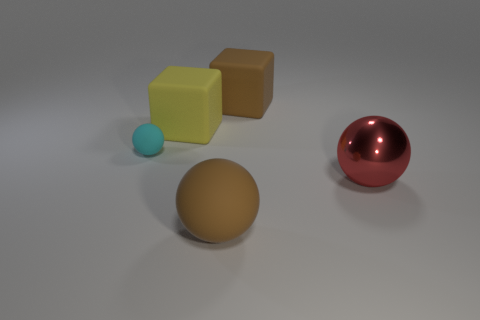Add 2 balls. How many objects exist? 7 Subtract all cubes. How many objects are left? 3 Add 4 yellow matte blocks. How many yellow matte blocks are left? 5 Add 2 rubber objects. How many rubber objects exist? 6 Subtract 0 gray cylinders. How many objects are left? 5 Subtract all large yellow cylinders. Subtract all large metal balls. How many objects are left? 4 